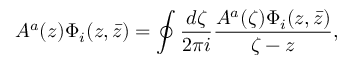<formula> <loc_0><loc_0><loc_500><loc_500>A ^ { a } ( z ) \Phi _ { i } ( z , \bar { z } ) = \oint { \frac { d \zeta } { 2 \pi i } } { \frac { A ^ { a } ( \zeta ) \Phi _ { i } ( z , \bar { z } ) } { \zeta - z } } ,</formula> 